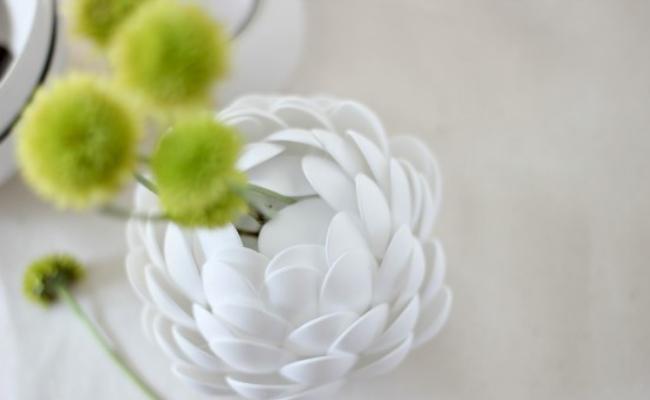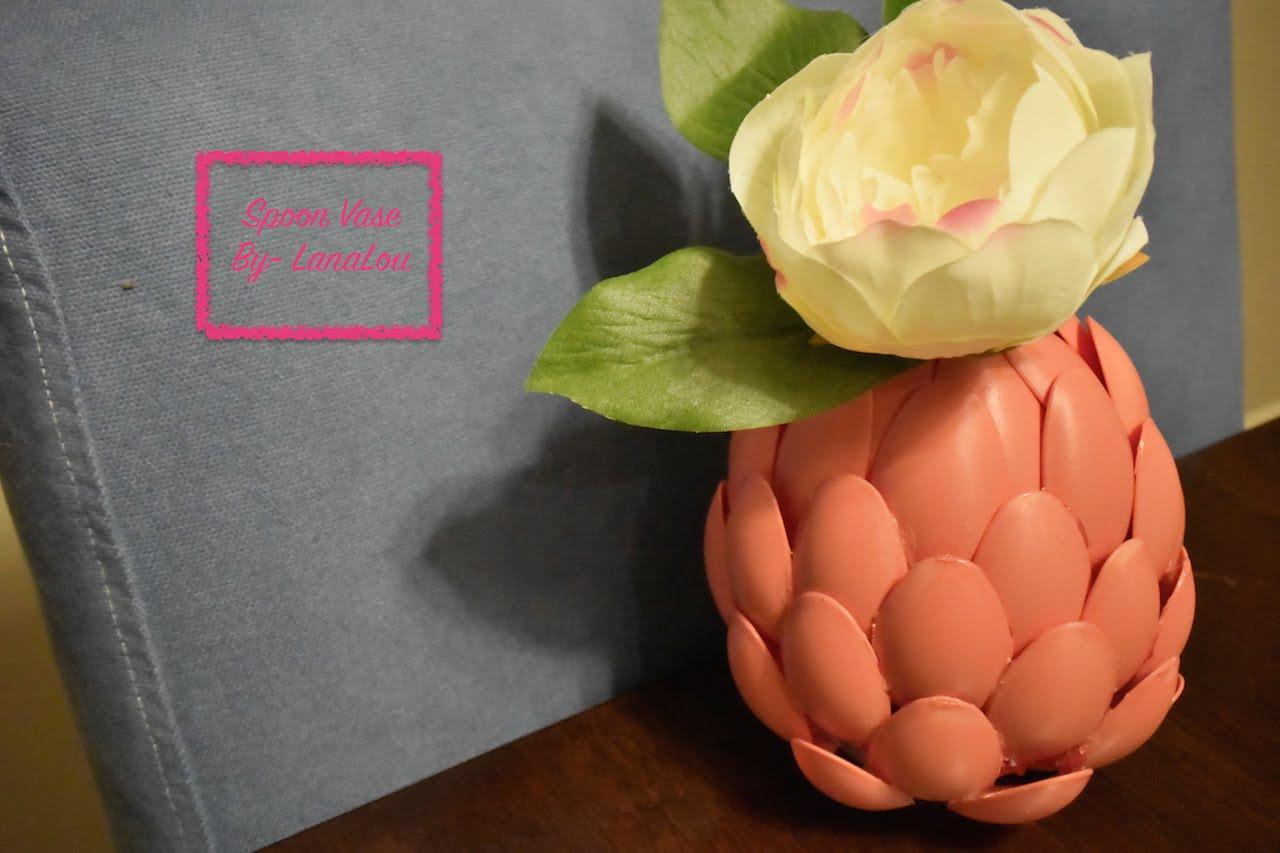The first image is the image on the left, the second image is the image on the right. Assess this claim about the two images: "There is a plant in a blue vase.". Correct or not? Answer yes or no. No. 